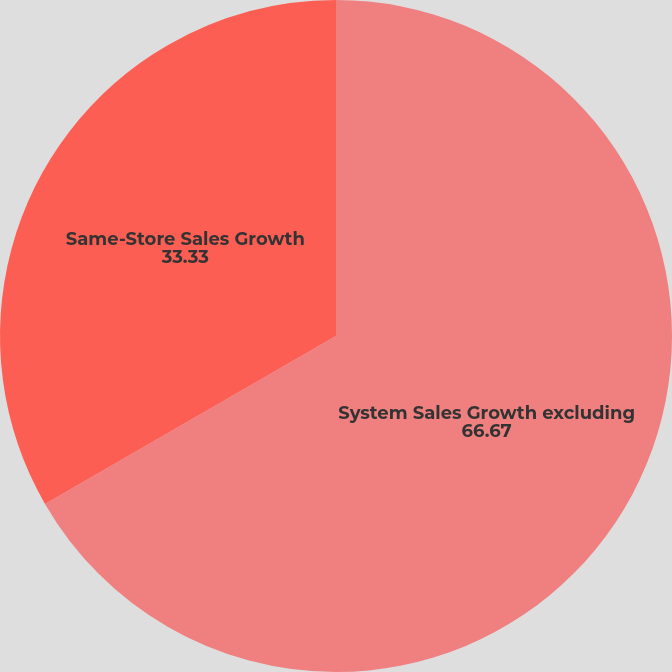Convert chart. <chart><loc_0><loc_0><loc_500><loc_500><pie_chart><fcel>System Sales Growth excluding<fcel>Same-Store Sales Growth<nl><fcel>66.67%<fcel>33.33%<nl></chart> 